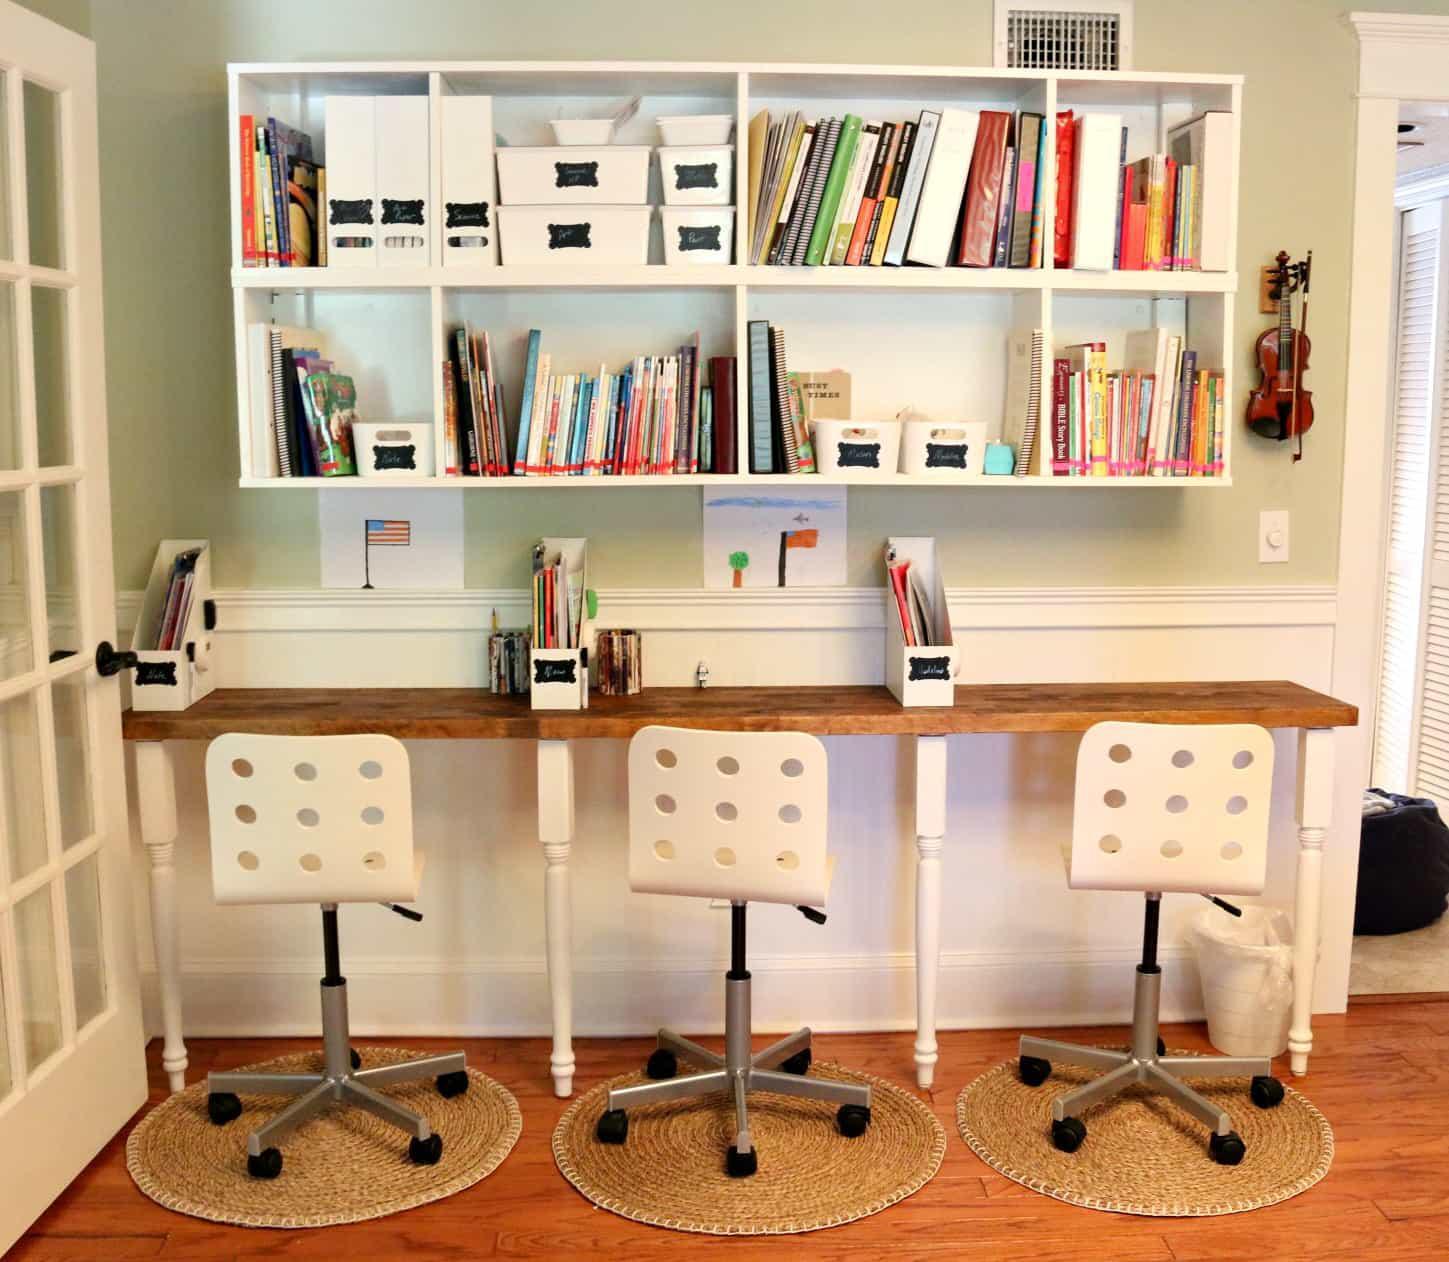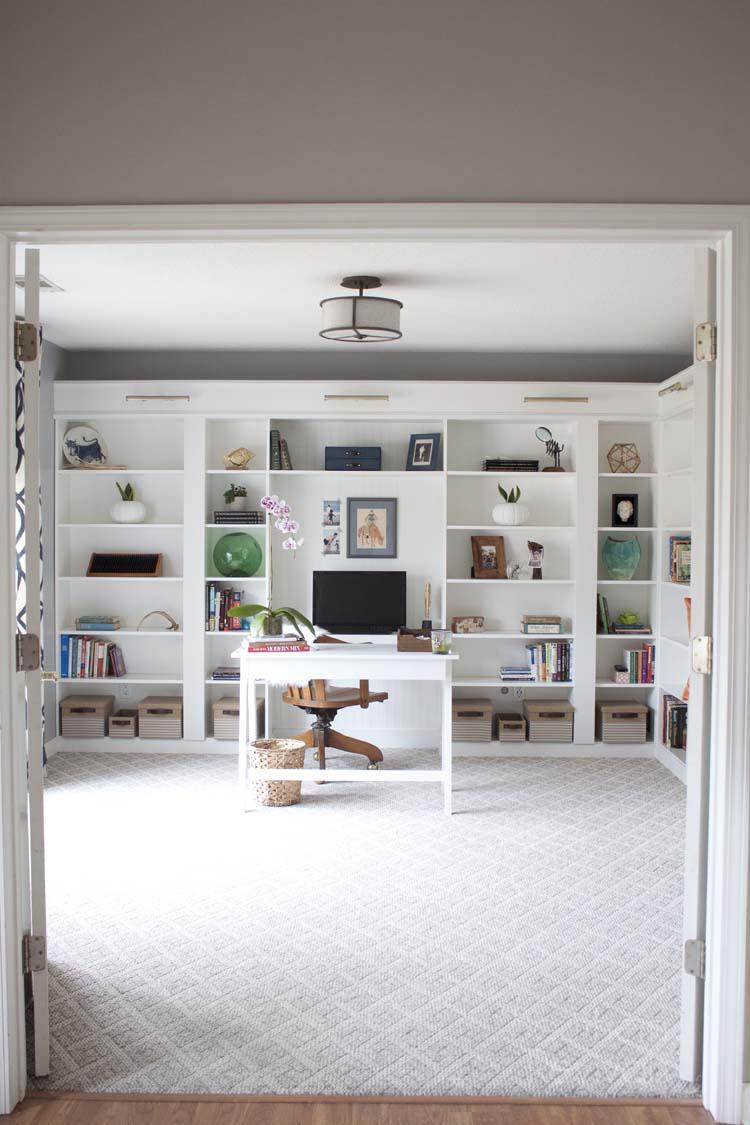The first image is the image on the left, the second image is the image on the right. For the images shown, is this caption "Three chairs with wheels are in front of a desk in one of the pictures." true? Answer yes or no. Yes. The first image is the image on the left, the second image is the image on the right. For the images shown, is this caption "One of the images features a desk with three chairs." true? Answer yes or no. Yes. 